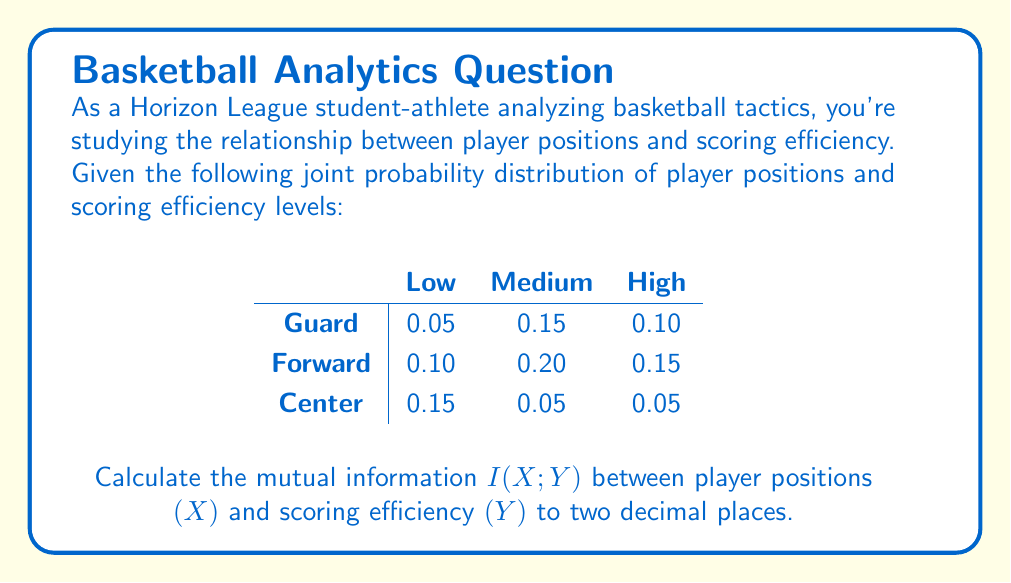Can you answer this question? To calculate the mutual information $I(X;Y)$, we'll follow these steps:

1) First, calculate the marginal probabilities:

   $P(X = \text{Guard}) = 0.05 + 0.15 + 0.10 = 0.30$
   $P(X = \text{Forward}) = 0.10 + 0.20 + 0.15 = 0.45$
   $P(X = \text{Center}) = 0.15 + 0.05 + 0.05 = 0.25$

   $P(Y = \text{Low}) = 0.05 + 0.10 + 0.15 = 0.30$
   $P(Y = \text{Medium}) = 0.15 + 0.20 + 0.05 = 0.40$
   $P(Y = \text{High}) = 0.10 + 0.15 + 0.05 = 0.30$

2) The mutual information is given by:

   $$I(X;Y) = \sum_{x \in X} \sum_{y \in Y} P(x,y) \log_2 \frac{P(x,y)}{P(x)P(y)}$$

3) Calculate each term:

   $0.05 \log_2 \frac{0.05}{0.30 \cdot 0.30} = 0.05 \log_2 0.5556 = -0.0423$
   $0.15 \log_2 \frac{0.15}{0.30 \cdot 0.40} = 0.15 \log_2 1.25 = 0.0361$
   $0.10 \log_2 \frac{0.10}{0.30 \cdot 0.30} = 0.10 \log_2 1.1111 = 0.0152$
   $0.10 \log_2 \frac{0.10}{0.45 \cdot 0.30} = 0.10 \log_2 0.7407 = -0.0341$
   $0.20 \log_2 \frac{0.20}{0.45 \cdot 0.40} = 0.20 \log_2 1.1111 = 0.0304$
   $0.15 \log_2 \frac{0.15}{0.45 \cdot 0.30} = 0.15 \log_2 1.1111 = 0.0228$
   $0.15 \log_2 \frac{0.15}{0.25 \cdot 0.30} = 0.15 \log_2 2 = 0.1505$
   $0.05 \log_2 \frac{0.05}{0.25 \cdot 0.40} = 0.05 \log_2 0.5 = -0.0500$
   $0.05 \log_2 \frac{0.05}{0.25 \cdot 0.30} = 0.05 \log_2 0.6667 = -0.0251$

4) Sum all these terms:

   $I(X;Y) = -0.0423 + 0.0361 + 0.0152 - 0.0341 + 0.0304 + 0.0228 + 0.1505 - 0.0500 - 0.0251 = 0.1035$

5) Rounding to two decimal places: $0.10$ bits.
Answer: $0.10$ bits 